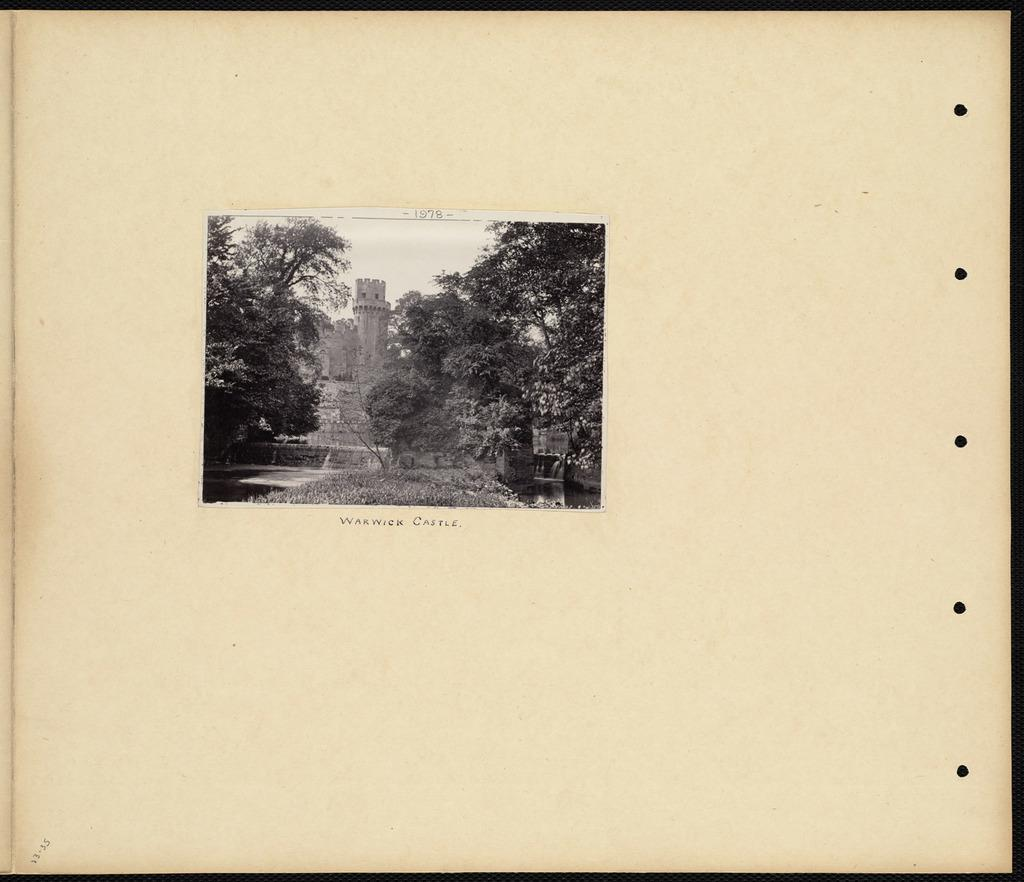What is depicted on the paper in the image? The paper contains a drawing of trees and a fort. Can you describe the drawing in more detail? The drawing on the paper features trees and a fort. What color is the eye in the image? There is no eye present in the image; it features a drawing of trees and a fort on a paper. 